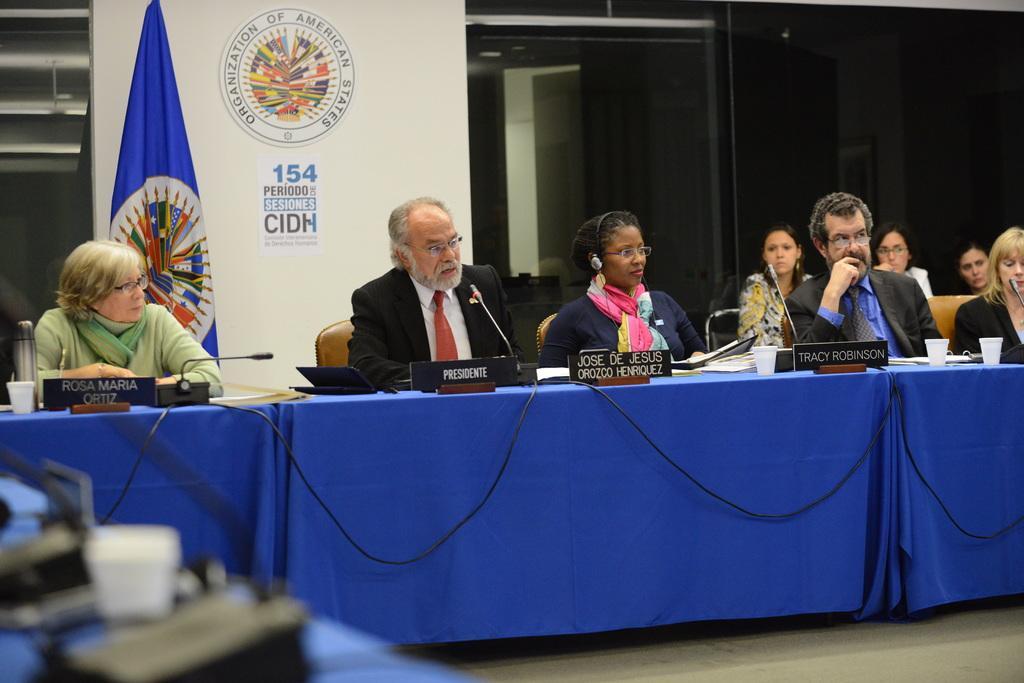Describe this image in one or two sentences. In this image in the there are some persons sitting on chairs, and there is one table. On the table there are some name boards, mike's, papers, glasses, and in the background there is a wall, flag and some logos, posters and door. On the left side there are some objects, at the bottom there is floor. 